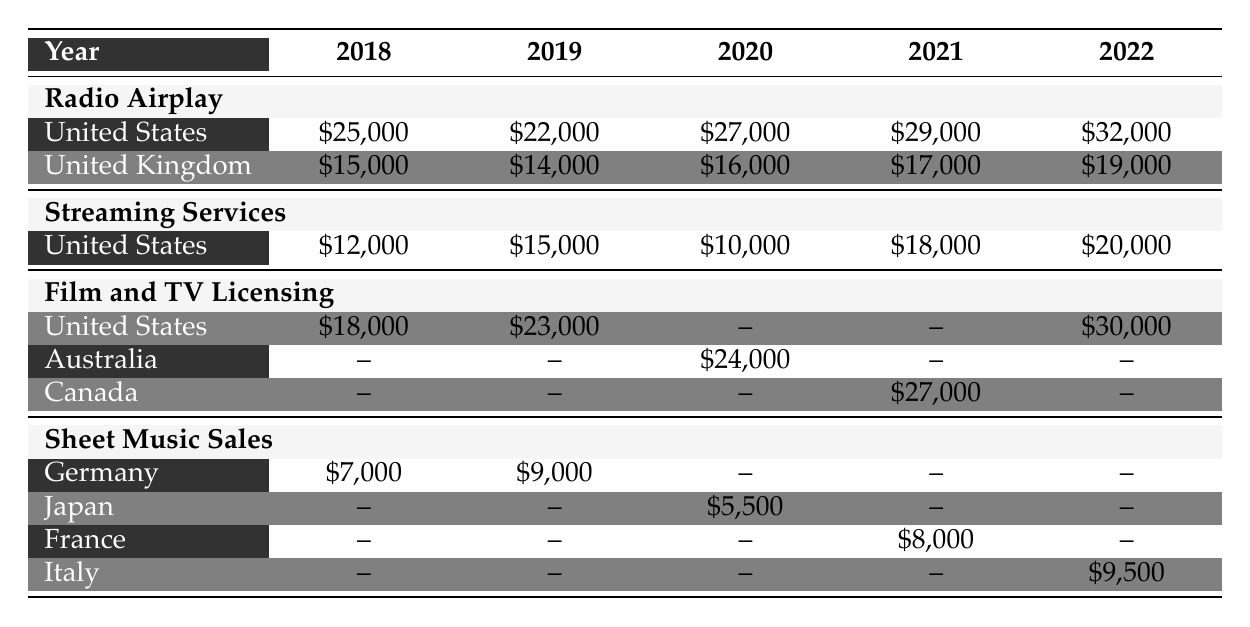What were the total royalties from Radio Airplay in the United States for 2020? The table shows that for Radio Airplay in the United States, the revenue for 2020 is $27,000.
Answer: 27000 Which year had the highest licensing fees from Film and TV Licensing in the United States? The Film and TV Licensing fees for the United States are $18,000 in 2018, $23,000 in 2019, and $30,000 in 2022. Therefore, 2022 has the highest fees.
Answer: 2022 What is the total revenue from Sheet Music Sales in Germany over the years listed? The revenues from Germany are $7,000 in 2018, $9,000 in 2019, and there are no revenues for 2020, 2021, and 2022. Summing these gives $7,000 + $9,000 = $16,000.
Answer: 16000 Did royalties from Streaming Services in the United Kingdom ever exceed $15,000 from 2018 to 2022? Looking at the revenues for Streaming Services in the United Kingdom: $0 in all years, they do not exceed $15,000.
Answer: No Which country earned the most from Film and TV Licensing in 2020 and what was the revenue? In 2020, the only revenue listed for Film and TV Licensing is from Australia, which earned $24,000. No other country is listed with revenue for that year.
Answer: Australia, 24000 What was the average revenue from Radio Airplay in the United Kingdom from 2018 to 2022? The revenues in the UK from Radio Airplay are $15,000 (2018), $14,000 (2019), $16,000 (2020), $17,000 (2021), and $19,000 (2022). The total revenue is $15,000 + $14,000 + $16,000 + $17,000 + $19,000 = $81,000. With 5 years of data, the average is $81,000 / 5 = $16,200.
Answer: 16200 What percentage increase in revenue from Streaming Services in the United States occurred from 2018 to 2022? The revenue from Streaming Services in the United States is $12,000 in 2018 and $20,000 in 2022. The increase is $20,000 - $12,000 = $8,000. To find the percentage increase: ($8,000 / $12,000) * 100 = approximately 66.67%.
Answer: 66.67% How much more did Radio Airplay in the United States earn in 2021 compared to 2019? Radio Airplay earned $22,000 in 2019 and $29,000 in 2021. The difference is $29,000 - $22,000 = $7,000.
Answer: 7000 Which year's total from Sheet Music Sales was lowest among the listed years? The Sheet Music Sales are $7,000 in 2018, $9,000 in 2019, $5,500 in 2020, and $9,500 in 2022. The minimum is $5,500 in 2020.
Answer: 2020 